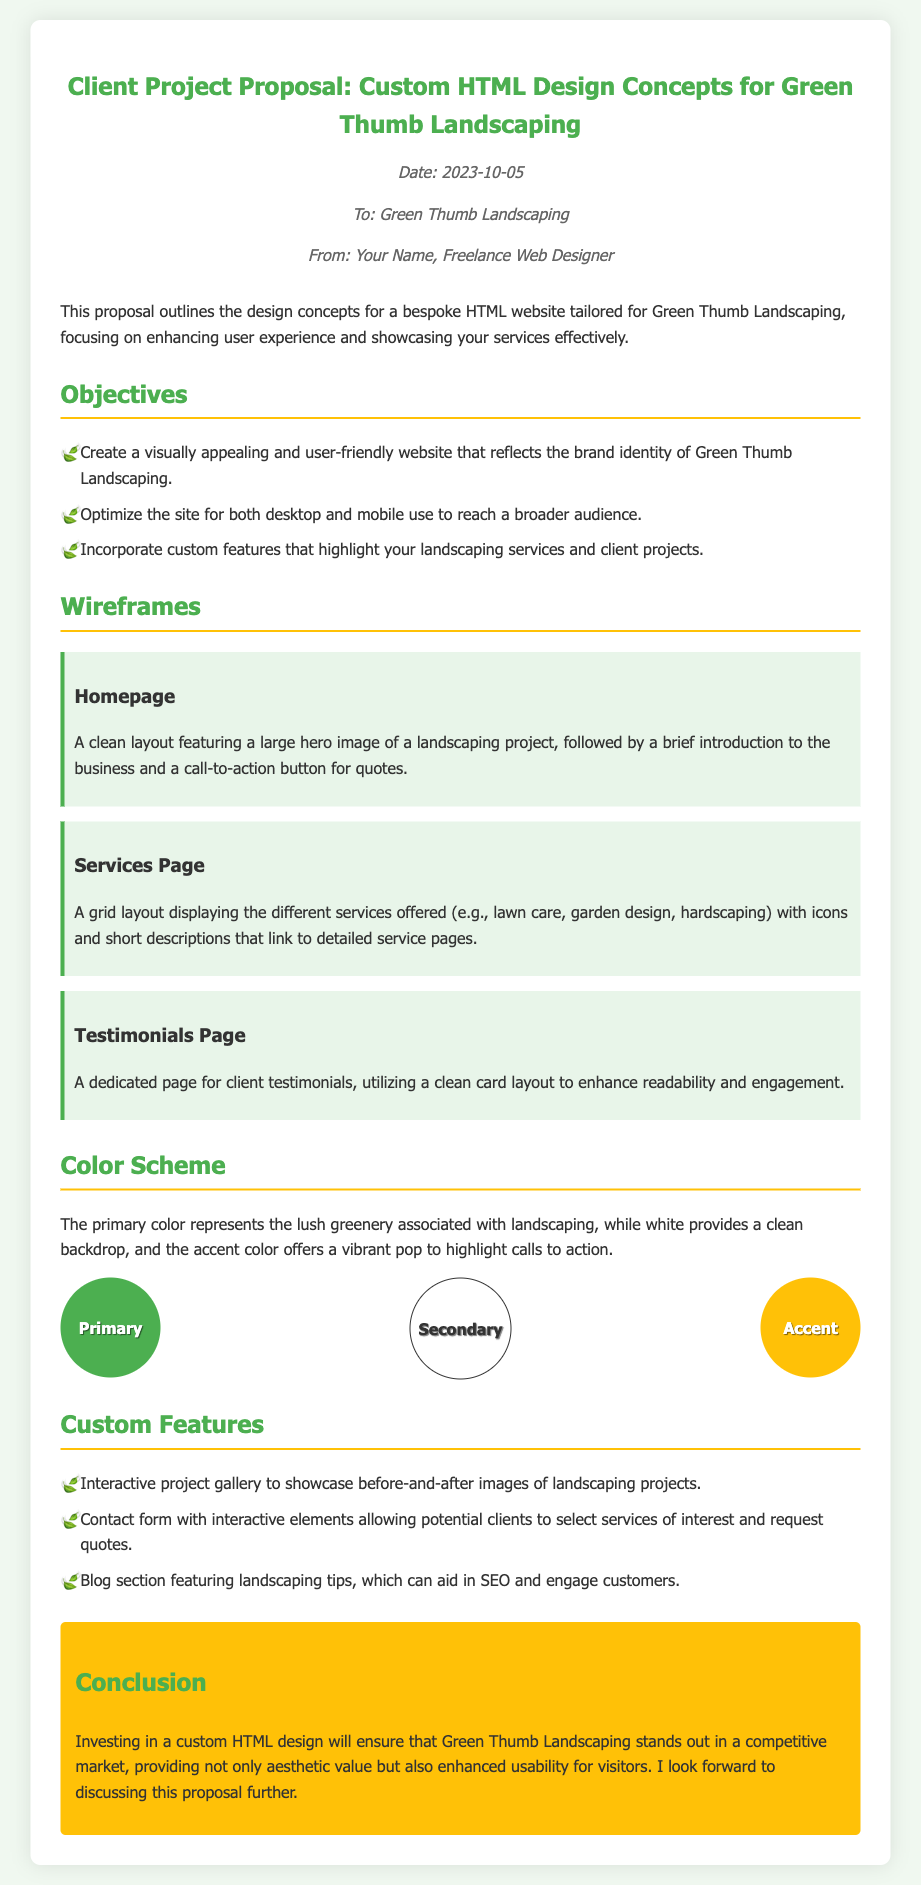what is the date of the memo? The date is mentioned in the document under the header section.
Answer: 2023-10-05 who is the memo addressed to? The recipient of the memo is stated directly in the header.
Answer: Green Thumb Landscaping what is the primary color used in the design? The primary color is described in the color scheme section as the lush greenery associated with landscaping.
Answer: #4CAF50 how many wireframes are presented in the document? The number of wireframes is listed under the wireframes section.
Answer: 3 what is one of the objectives of the project? One of the objectives is listed in the objectives section, focusing on user experience.
Answer: Create a visually appealing and user-friendly website what is the accent color mentioned? The color scheme section lists the accent color used in the design concepts.
Answer: #FFC107 what is suggested for the Testimonials Page layout? The document describes the layout for this page in the wireframes section.
Answer: Clean card layout what type of section can aid in SEO? The document suggests a specific section that can improve search engine optimization.
Answer: Blog section what is the conclusion's main point? The conclusion summarizes the overall benefit of the design proposed in the memo.
Answer: Stand out in a competitive market 